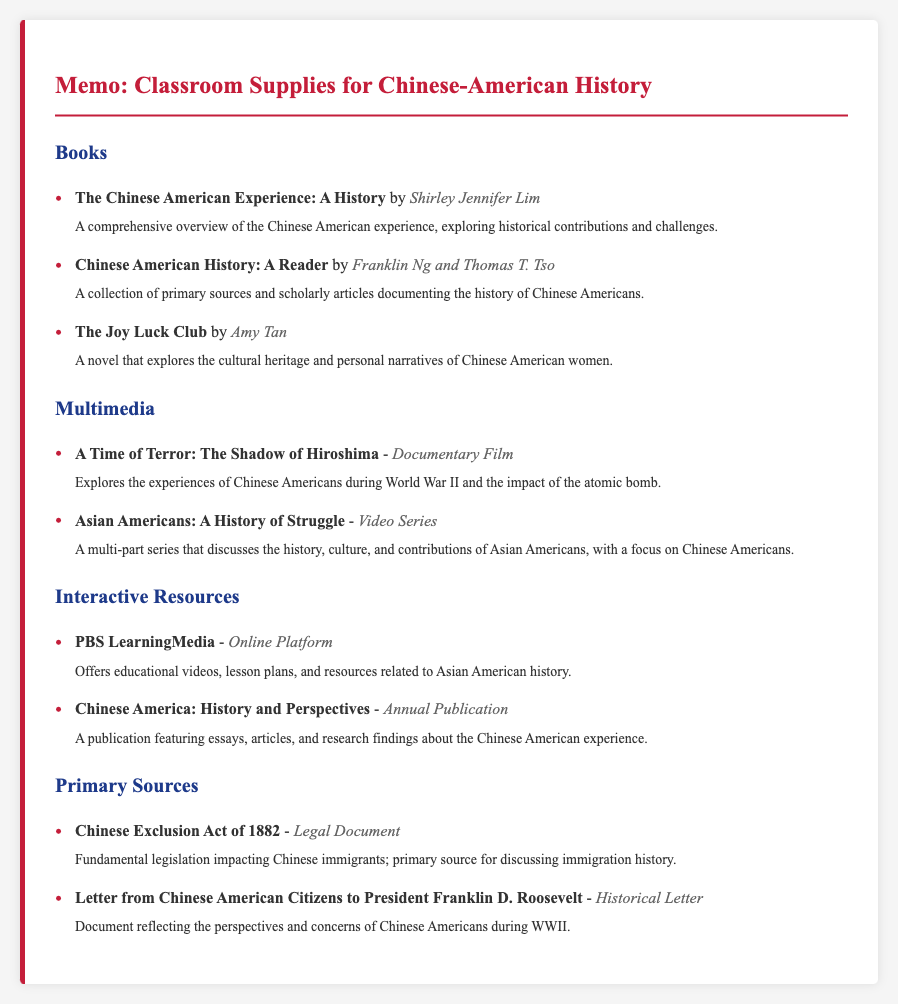What is the title of the first book listed? The title of the first book listed is "The Chinese American Experience: A History".
Answer: The Chinese American Experience: A History Who is the author of "The Joy Luck Club"? The author of "The Joy Luck Club" is Amy Tan.
Answer: Amy Tan What type of resource is "PBS LearningMedia"? "PBS LearningMedia" is classified as an "Online Platform".
Answer: Online Platform How many multimedia resources are listed in the document? There are 2 multimedia resources listed in the document.
Answer: 2 What primary source discusses the Chinese Exclusion Act of 1882? The primary source is titled "Chinese Exclusion Act of 1882".
Answer: Chinese Exclusion Act of 1882 What is the focus of the "Asian Americans: A History of Struggle" video series? The focus is on the history, culture, and contributions of Asian Americans, particularly Chinese Americans.
Answer: History, culture, and contributions of Asian Americans What publication features essays and articles about the Chinese American experience? The publication is "Chinese America: History and Perspectives".
Answer: Chinese America: History and Perspectives What type of document is the "Letter from Chinese American Citizens to President Franklin D. Roosevelt"? It is classified as a "Historical Letter".
Answer: Historical Letter 